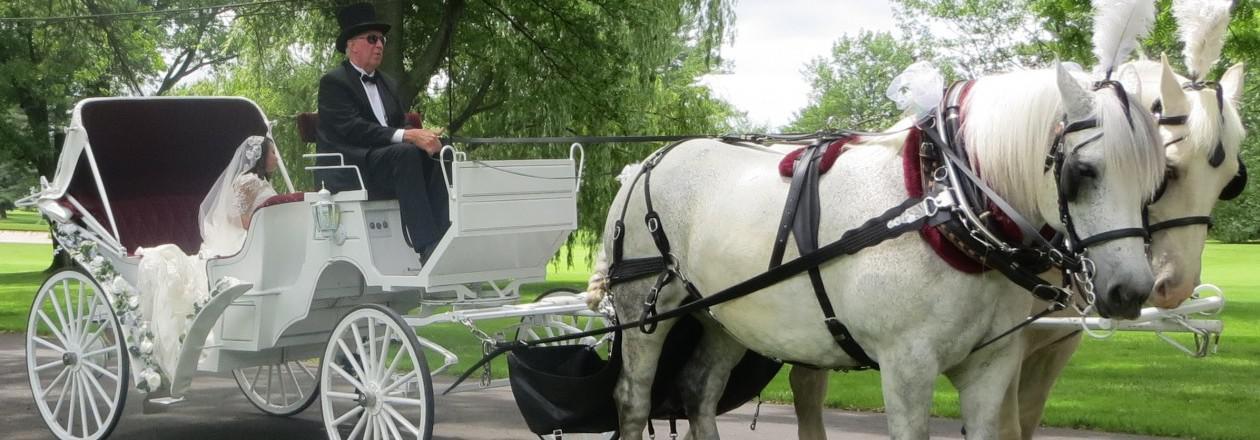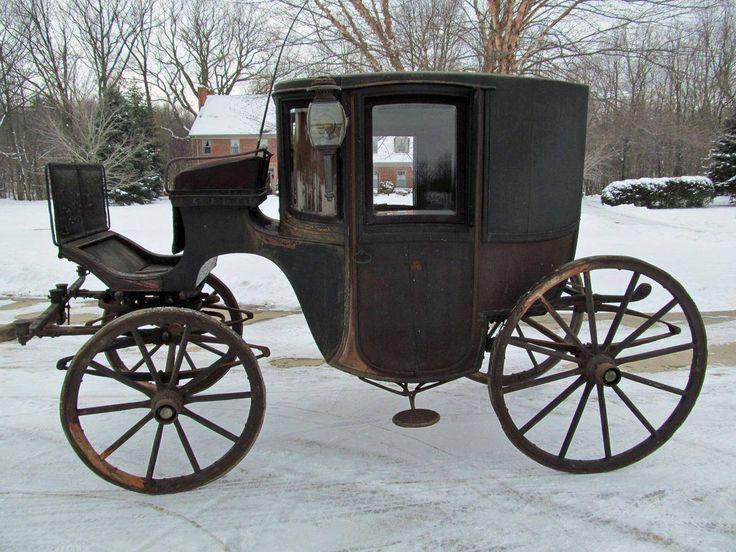The first image is the image on the left, the second image is the image on the right. For the images shown, is this caption "There are multiple people being pulled in a carriage in the street by two horses in the right image." true? Answer yes or no. No. The first image is the image on the left, the second image is the image on the right. Considering the images on both sides, is "There is a carriage without any horses attached to it." valid? Answer yes or no. Yes. 